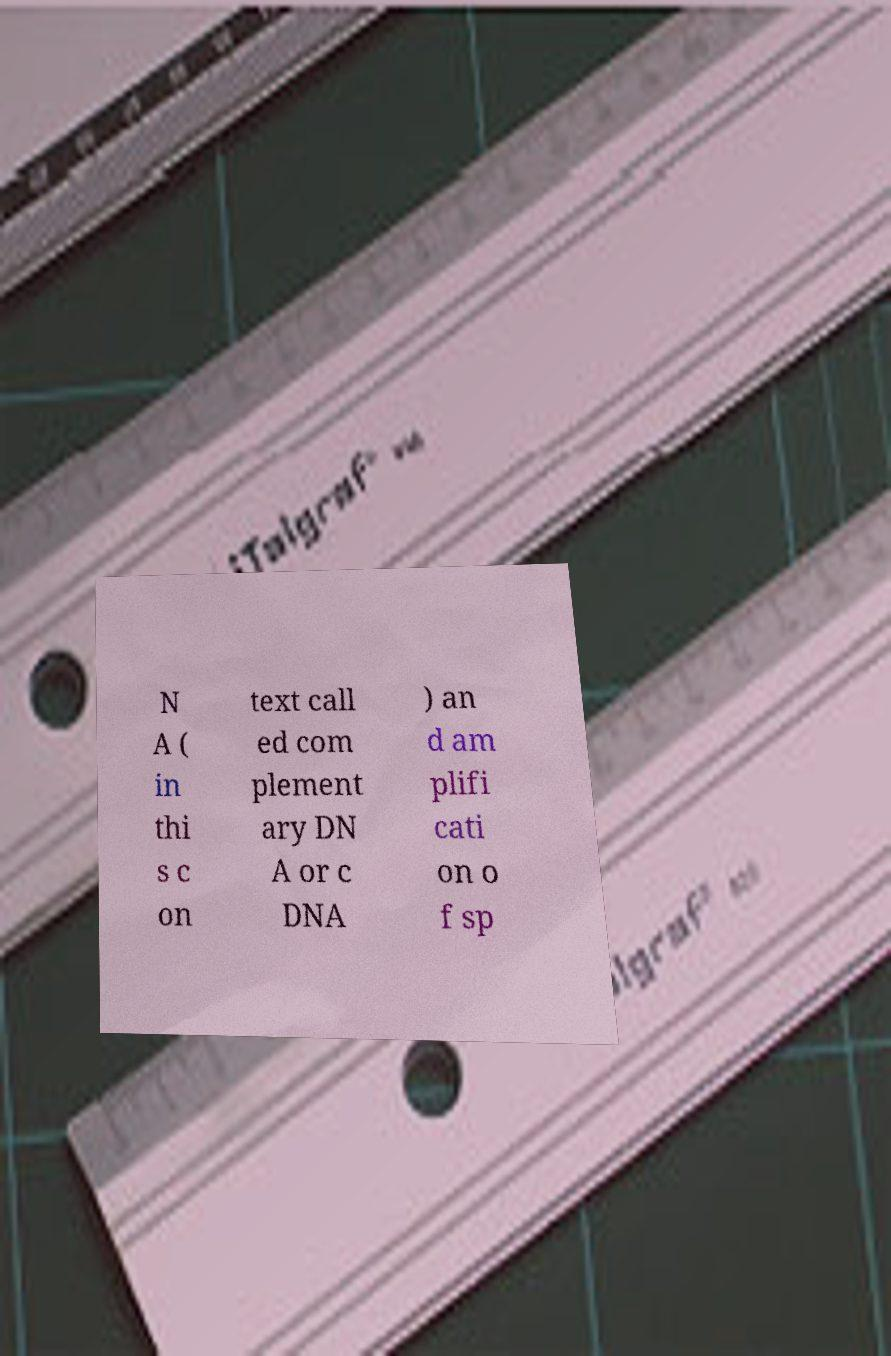What messages or text are displayed in this image? I need them in a readable, typed format. N A ( in thi s c on text call ed com plement ary DN A or c DNA ) an d am plifi cati on o f sp 